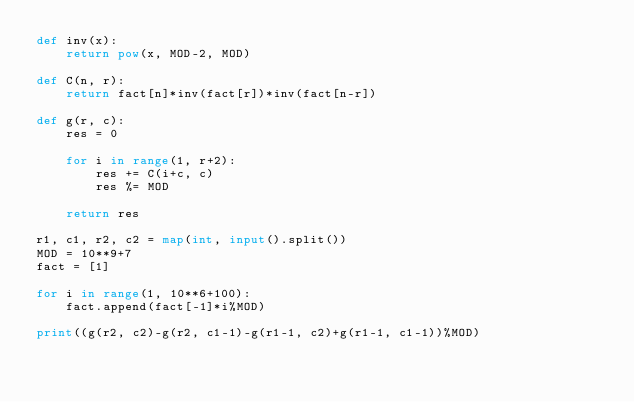<code> <loc_0><loc_0><loc_500><loc_500><_Python_>def inv(x):
    return pow(x, MOD-2, MOD)

def C(n, r):
    return fact[n]*inv(fact[r])*inv(fact[n-r])
    
def g(r, c):
    res = 0
    
    for i in range(1, r+2):
        res += C(i+c, c)
        res %= MOD
    
    return res

r1, c1, r2, c2 = map(int, input().split())
MOD = 10**9+7
fact = [1]

for i in range(1, 10**6+100):
    fact.append(fact[-1]*i%MOD)

print((g(r2, c2)-g(r2, c1-1)-g(r1-1, c2)+g(r1-1, c1-1))%MOD)</code> 